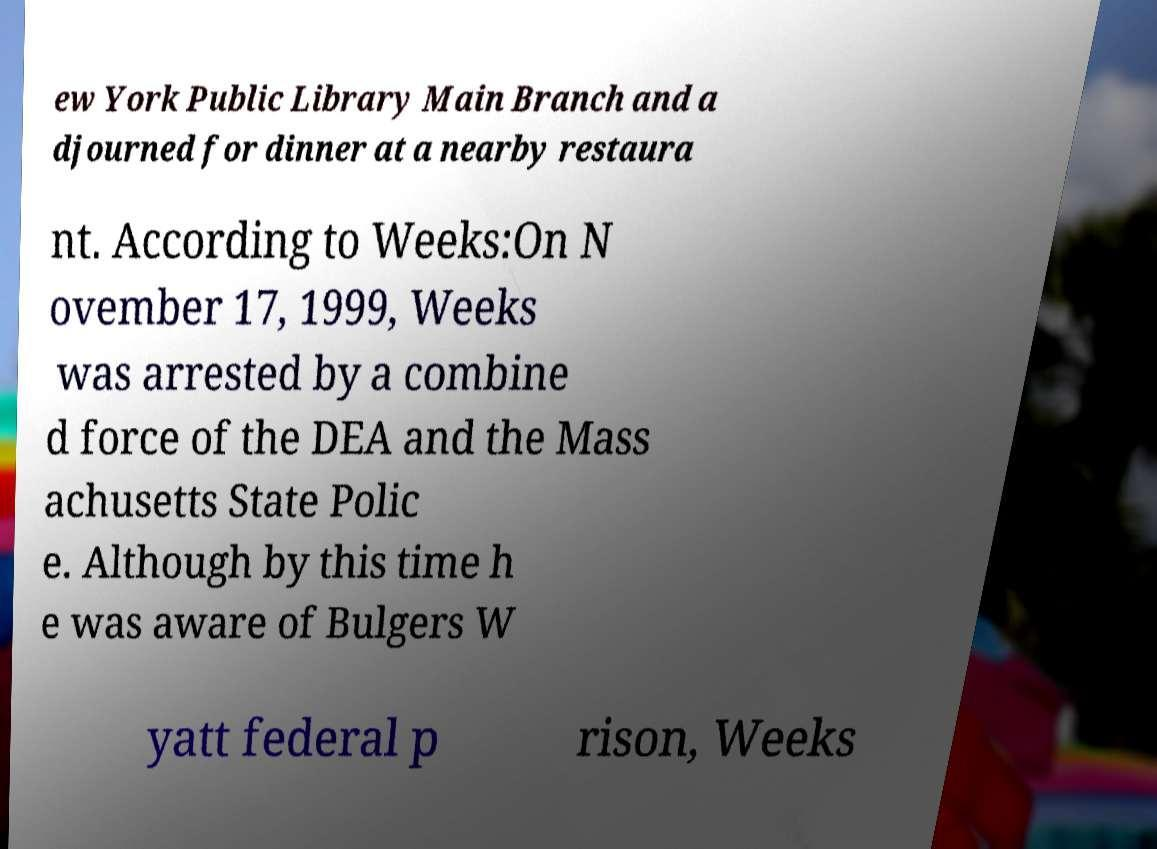For documentation purposes, I need the text within this image transcribed. Could you provide that? ew York Public Library Main Branch and a djourned for dinner at a nearby restaura nt. According to Weeks:On N ovember 17, 1999, Weeks was arrested by a combine d force of the DEA and the Mass achusetts State Polic e. Although by this time h e was aware of Bulgers W yatt federal p rison, Weeks 